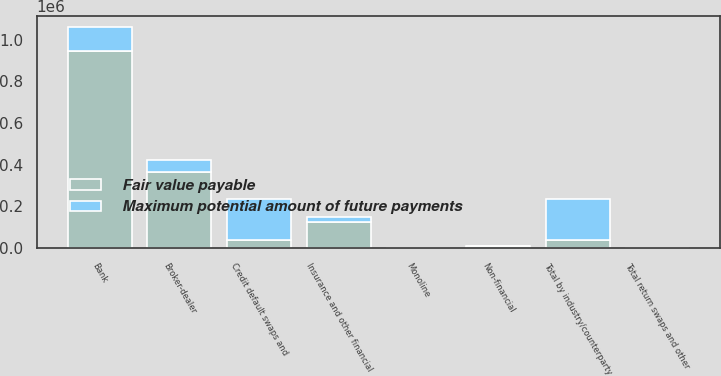<chart> <loc_0><loc_0><loc_500><loc_500><stacked_bar_chart><ecel><fcel>Bank<fcel>Broker-dealer<fcel>Monoline<fcel>Non-financial<fcel>Insurance and other financial<fcel>Total by industry/counterparty<fcel>Credit default swaps and<fcel>Total return swaps and other<nl><fcel>Fair value payable<fcel>943949<fcel>365664<fcel>139<fcel>7540<fcel>125988<fcel>38579<fcel>38579<fcel>1905<nl><fcel>Maximum potential amount of future payments<fcel>118428<fcel>55458<fcel>91<fcel>2556<fcel>21700<fcel>198233<fcel>197981<fcel>252<nl></chart> 